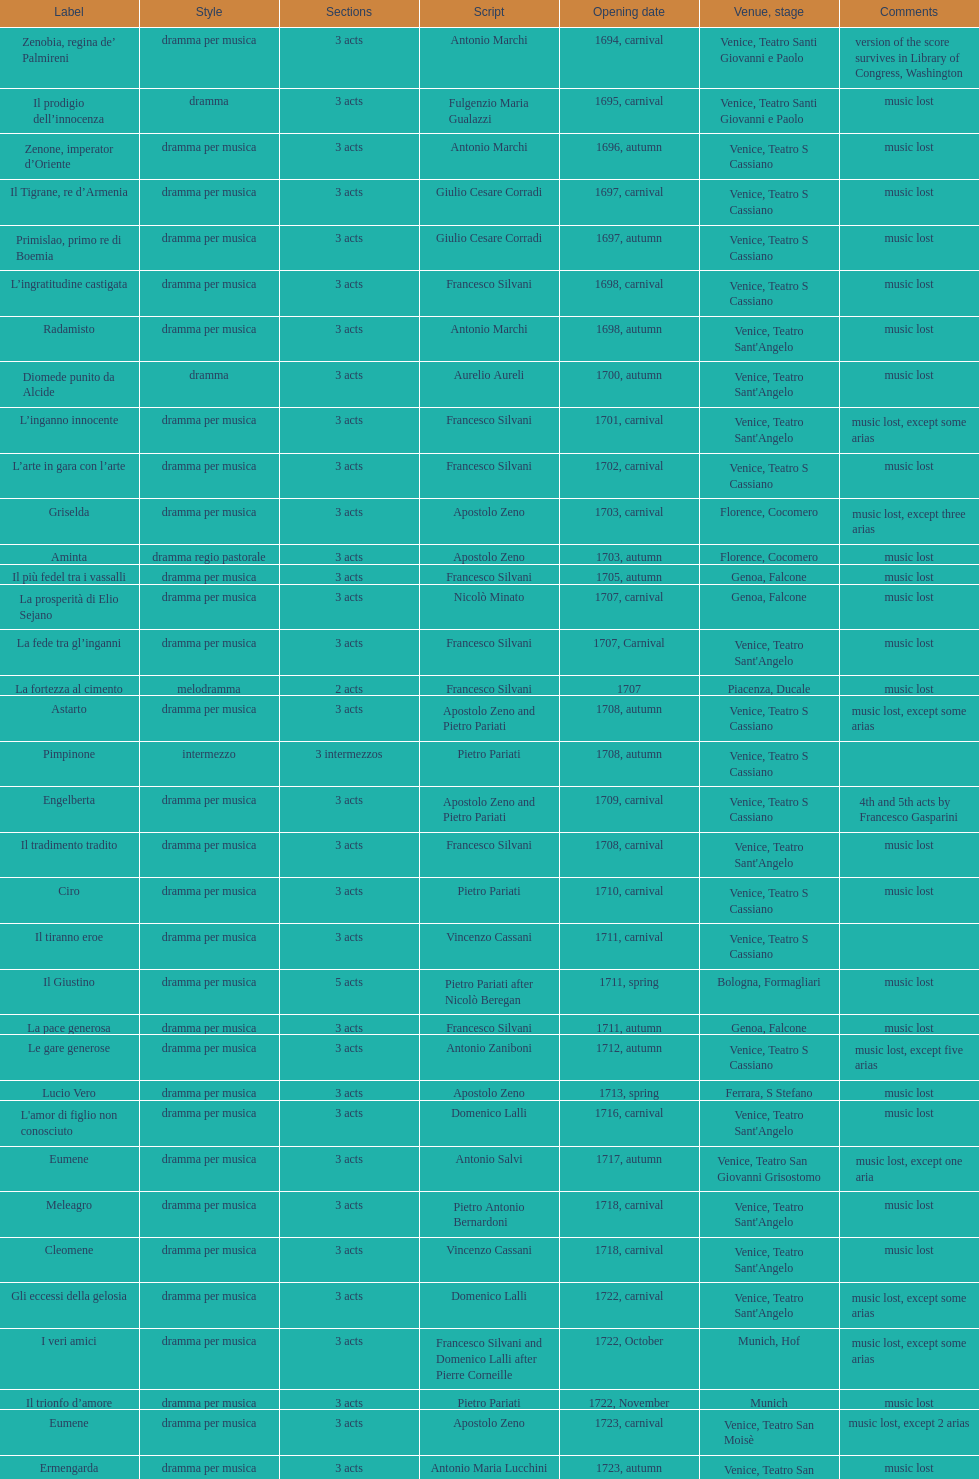What is next after ardelinda? Candalide. 